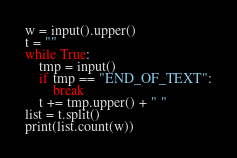<code> <loc_0><loc_0><loc_500><loc_500><_Python_>w = input().upper()
t = ""
while True:
    tmp = input()
    if tmp == "END_OF_TEXT":
        break
    t += tmp.upper() + " "
list = t.split()
print(list.count(w))

</code> 